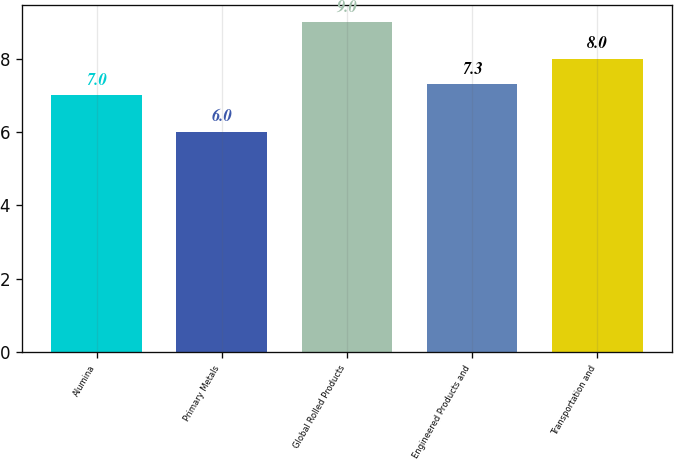Convert chart to OTSL. <chart><loc_0><loc_0><loc_500><loc_500><bar_chart><fcel>Alumina<fcel>Primary Metals<fcel>Global Rolled Products<fcel>Engineered Products and<fcel>Transportation and<nl><fcel>7<fcel>6<fcel>9<fcel>7.3<fcel>8<nl></chart> 